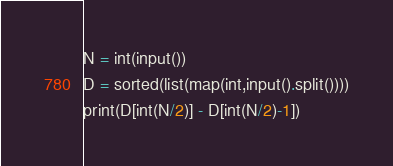<code> <loc_0><loc_0><loc_500><loc_500><_Python_>N = int(input())
D = sorted(list(map(int,input().split())))
print(D[int(N/2)] - D[int(N/2)-1])
</code> 